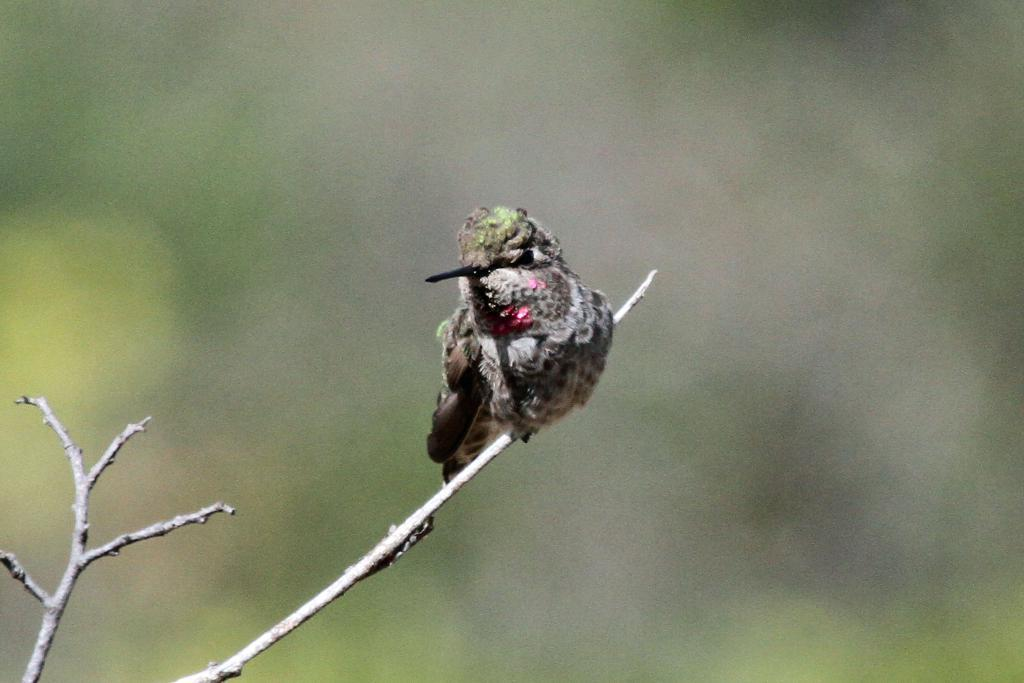What type of animal is in the image? There is a bird in the image. Where is the bird located? The bird is on a tree branch. Can you describe the background of the image? The background of the image is blurred. What type of nut is the bird holding in its beak in the image? There is no nut visible in the image; the bird is simply perched on a tree branch. 